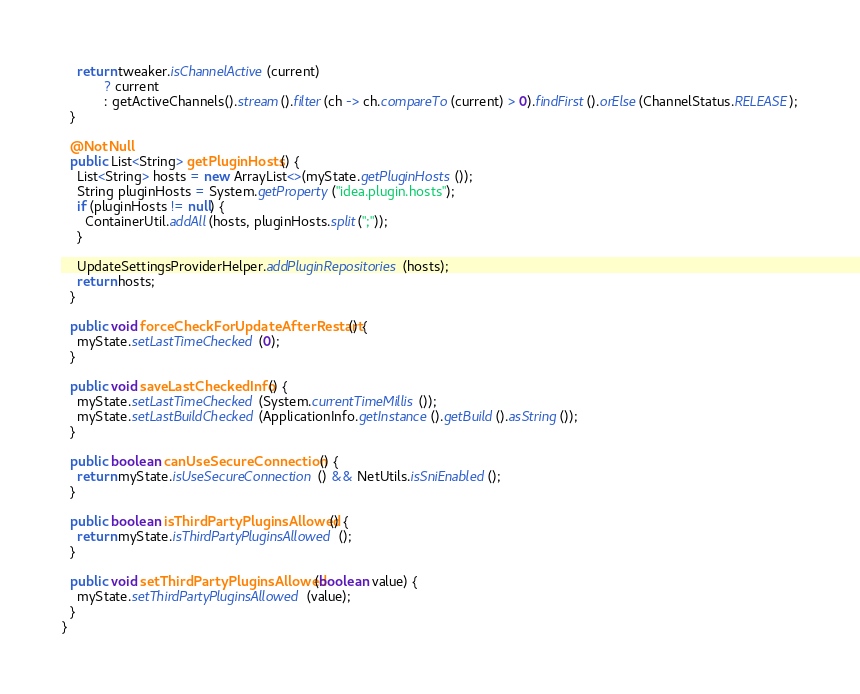<code> <loc_0><loc_0><loc_500><loc_500><_Java_>    return tweaker.isChannelActive(current)
           ? current
           : getActiveChannels().stream().filter(ch -> ch.compareTo(current) > 0).findFirst().orElse(ChannelStatus.RELEASE);
  }

  @NotNull
  public List<String> getPluginHosts() {
    List<String> hosts = new ArrayList<>(myState.getPluginHosts());
    String pluginHosts = System.getProperty("idea.plugin.hosts");
    if (pluginHosts != null) {
      ContainerUtil.addAll(hosts, pluginHosts.split(";"));
    }

    UpdateSettingsProviderHelper.addPluginRepositories(hosts);
    return hosts;
  }

  public void forceCheckForUpdateAfterRestart() {
    myState.setLastTimeChecked(0);
  }

  public void saveLastCheckedInfo() {
    myState.setLastTimeChecked(System.currentTimeMillis());
    myState.setLastBuildChecked(ApplicationInfo.getInstance().getBuild().asString());
  }

  public boolean canUseSecureConnection() {
    return myState.isUseSecureConnection() && NetUtils.isSniEnabled();
  }

  public boolean isThirdPartyPluginsAllowed() {
    return myState.isThirdPartyPluginsAllowed();
  }

  public void setThirdPartyPluginsAllowed(boolean value) {
    myState.setThirdPartyPluginsAllowed(value);
  }
}</code> 